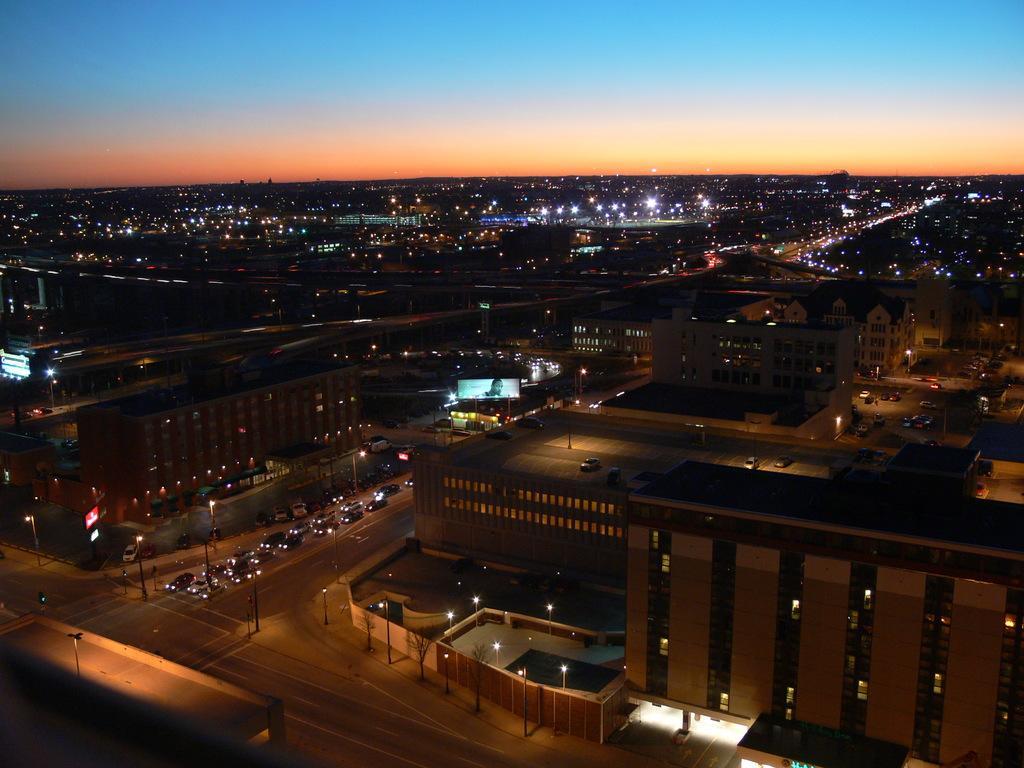Please provide a concise description of this image. In this image we can see buildings and glass windows, after that we can see vehicles on the road, at the top we can see the sky. 